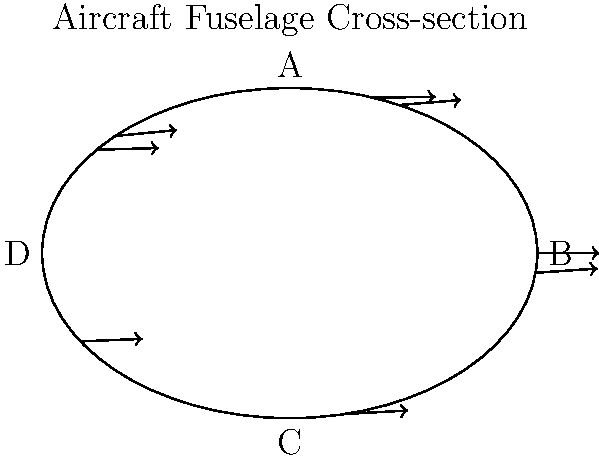During high-altitude mountain operations, an aircraft experiences increased stress on its fuselage due to the pressure differential. Given the cross-section of the fuselage shown above, which region (A, B, C, or D) is likely to experience the highest stress concentration? Explain your reasoning considering the geometry and pressure distribution. To determine the region with the highest stress concentration, we need to consider several factors:

1. Geometry: The fuselage cross-section is elliptical, with the major axis oriented horizontally.

2. Pressure differential: At high altitudes, the pressure inside the cabin is higher than the outside atmospheric pressure, causing the fuselage to experience outward forces.

3. Stress distribution in curved structures: In pressurized vessels with curved surfaces, stress is inversely proportional to the radius of curvature. Smaller radii of curvature lead to higher stress concentrations.

4. Analyzing the regions:
   A and C: Located at the top and bottom of the ellipse, respectively. These areas have a larger radius of curvature.
   B and D: Located at the sides of the ellipse. These areas have a smaller radius of curvature.

5. Stress concentration: Due to the smaller radius of curvature, regions B and D will experience higher stress concentrations compared to A and C.

6. Symmetry: Since the ellipse is symmetrical, regions B and D will experience equal stress concentrations.

Therefore, both regions B and D are likely to experience the highest stress concentration. However, since the question asks for a single region, we can choose either B or D as the answer.

The stress concentration in these regions can be approximated using the formula:

$$ \sigma = \frac{pr}{t} $$

Where $\sigma$ is the hoop stress, $p$ is the pressure differential, $r$ is the radius of curvature, and $t$ is the thickness of the fuselage wall.

For an elliptical cross-section, the radius of curvature at the ends of the major axis (B and D) is smaller than at the ends of the minor axis (A and C), resulting in higher stress concentrations.
Answer: Region B (or D) 